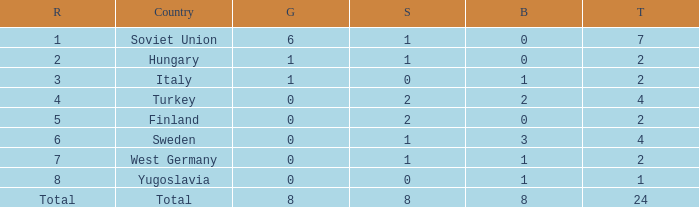What is the sum of Total, when Silver is 0, and when Gold is 1? 2.0. 